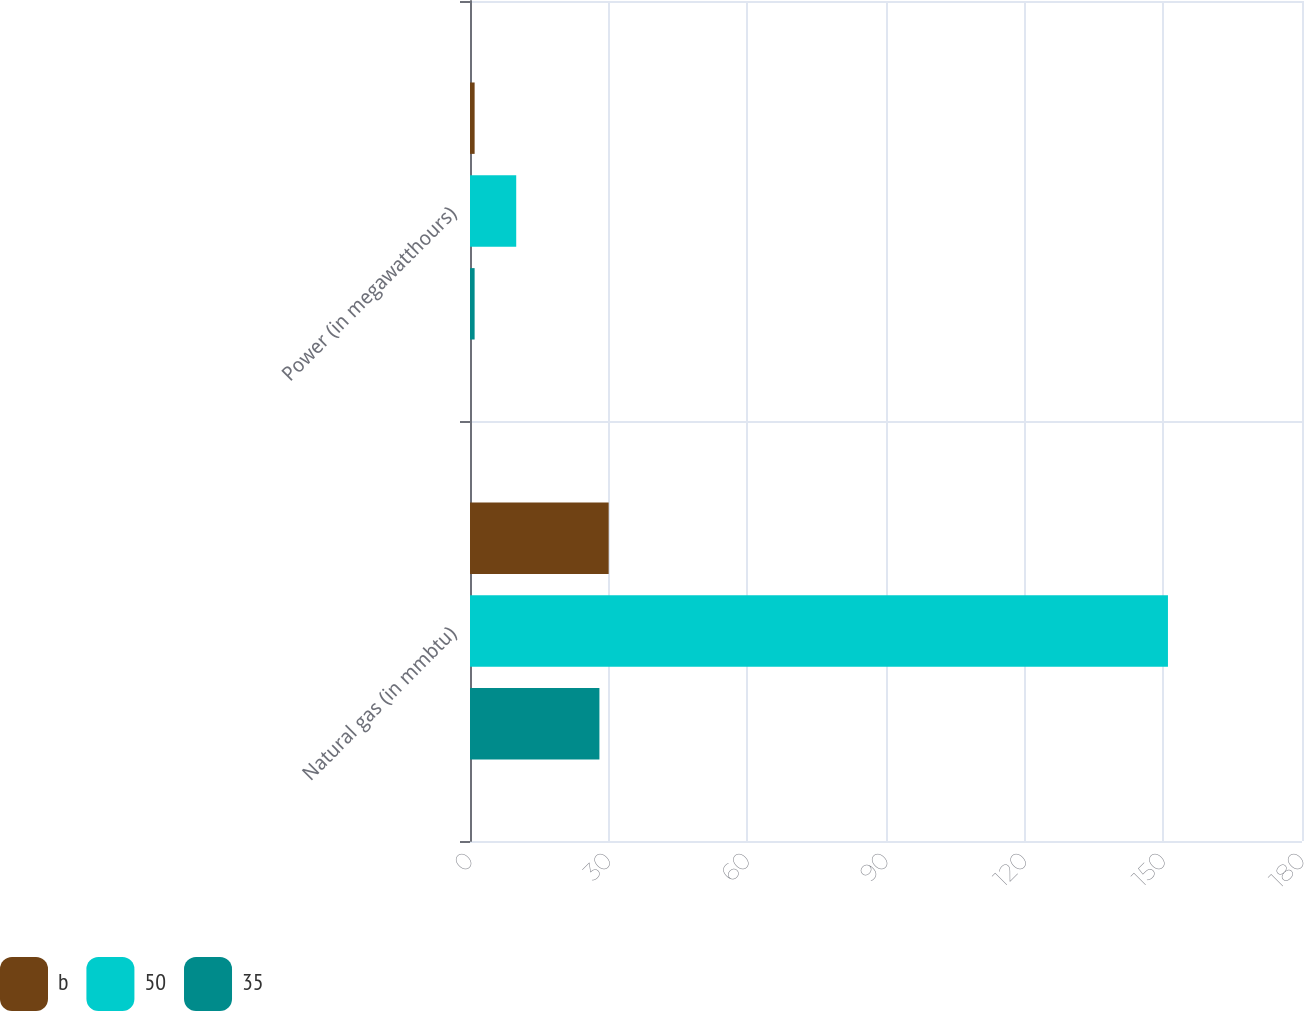Convert chart to OTSL. <chart><loc_0><loc_0><loc_500><loc_500><stacked_bar_chart><ecel><fcel>Natural gas (in mmbtu)<fcel>Power (in megawatthours)<nl><fcel>b<fcel>30<fcel>1<nl><fcel>50<fcel>151<fcel>10<nl><fcel>35<fcel>28<fcel>1<nl></chart> 